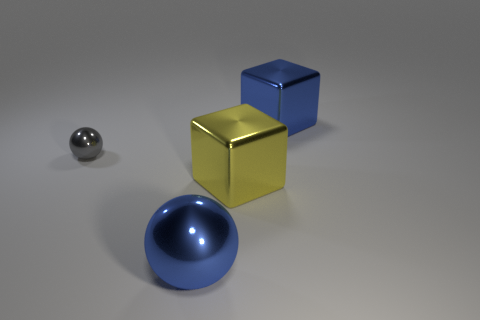How many gray objects are spheres or large blocks?
Your response must be concise. 1. Are there fewer gray objects that are on the right side of the small gray thing than gray metallic cubes?
Your answer should be very brief. No. There is a large blue metallic object that is on the right side of the large blue shiny sphere; what number of big cubes are on the left side of it?
Offer a terse response. 1. How many other things are there of the same size as the blue metallic sphere?
Make the answer very short. 2. How many things are either big cubes or blue blocks that are to the right of the yellow metallic thing?
Offer a terse response. 2. Are there fewer big yellow blocks than small gray matte balls?
Offer a terse response. No. The metallic sphere that is right of the small gray ball to the left of the big yellow object is what color?
Offer a very short reply. Blue. How many matte things are either small cyan blocks or big blue cubes?
Provide a short and direct response. 0. Are the sphere behind the large metallic ball and the large blue sphere that is left of the large yellow shiny object made of the same material?
Your answer should be very brief. Yes. Are any small cyan matte blocks visible?
Give a very brief answer. No. 